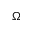<formula> <loc_0><loc_0><loc_500><loc_500>\Omega</formula> 